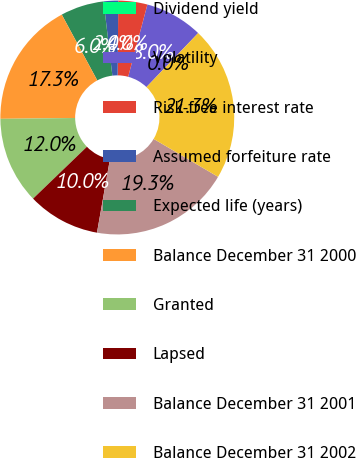Convert chart. <chart><loc_0><loc_0><loc_500><loc_500><pie_chart><fcel>Dividend yield<fcel>Volatility<fcel>Risk-free interest rate<fcel>Assumed forfeiture rate<fcel>Expected life (years)<fcel>Balance December 31 2000<fcel>Granted<fcel>Lapsed<fcel>Balance December 31 2001<fcel>Balance December 31 2002<nl><fcel>0.0%<fcel>8.01%<fcel>4.01%<fcel>2.0%<fcel>6.01%<fcel>17.3%<fcel>12.02%<fcel>10.02%<fcel>19.31%<fcel>21.31%<nl></chart> 